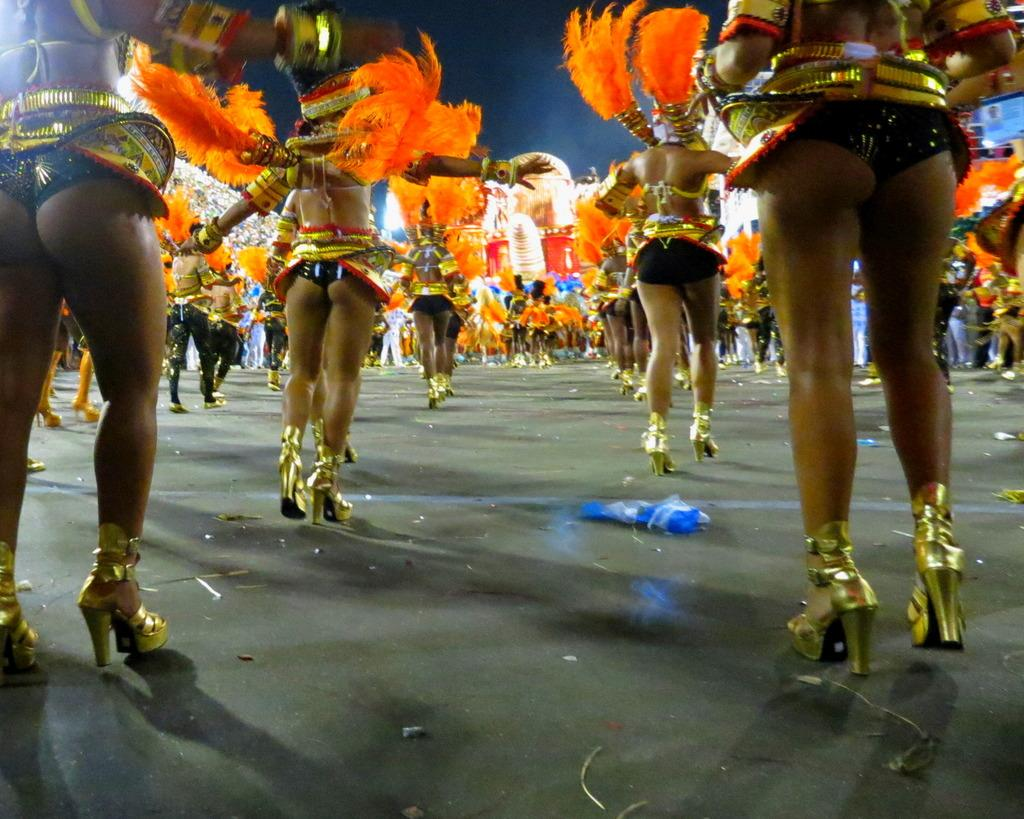What are the people in the image doing? The people in the image are dancing. What colors are the people wearing? The people are wearing black and orange color dress. What can be seen in the background of the image? There is a screen in the background of the image. What color is the screen? The screen is blue in color. Are there any plants growing on the screen in the image? There is no mention of plants in the image; the screen is blue in color. Can you see any flames coming from the people's hands while they are dancing? There is no indication of flames in the image; the people are simply dancing while wearing black and orange dresses. 